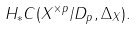Convert formula to latex. <formula><loc_0><loc_0><loc_500><loc_500>H _ { * } C ( X ^ { \times p } / D _ { p } , \Delta _ { X } ) .</formula> 